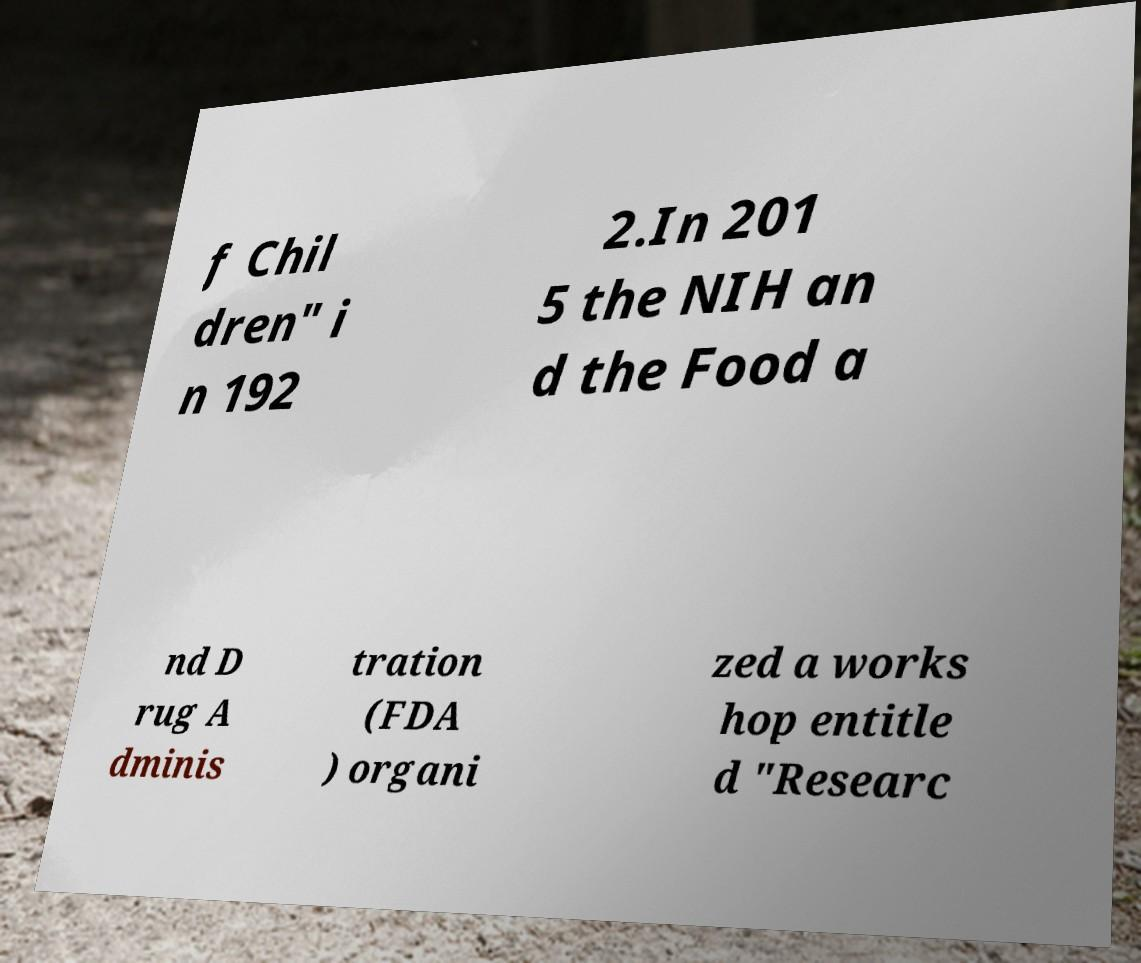There's text embedded in this image that I need extracted. Can you transcribe it verbatim? f Chil dren" i n 192 2.In 201 5 the NIH an d the Food a nd D rug A dminis tration (FDA ) organi zed a works hop entitle d "Researc 